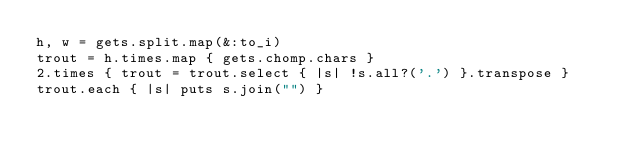<code> <loc_0><loc_0><loc_500><loc_500><_Ruby_>h, w = gets.split.map(&:to_i)
trout = h.times.map { gets.chomp.chars }
2.times { trout = trout.select { |s| !s.all?('.') }.transpose }
trout.each { |s| puts s.join("") }</code> 